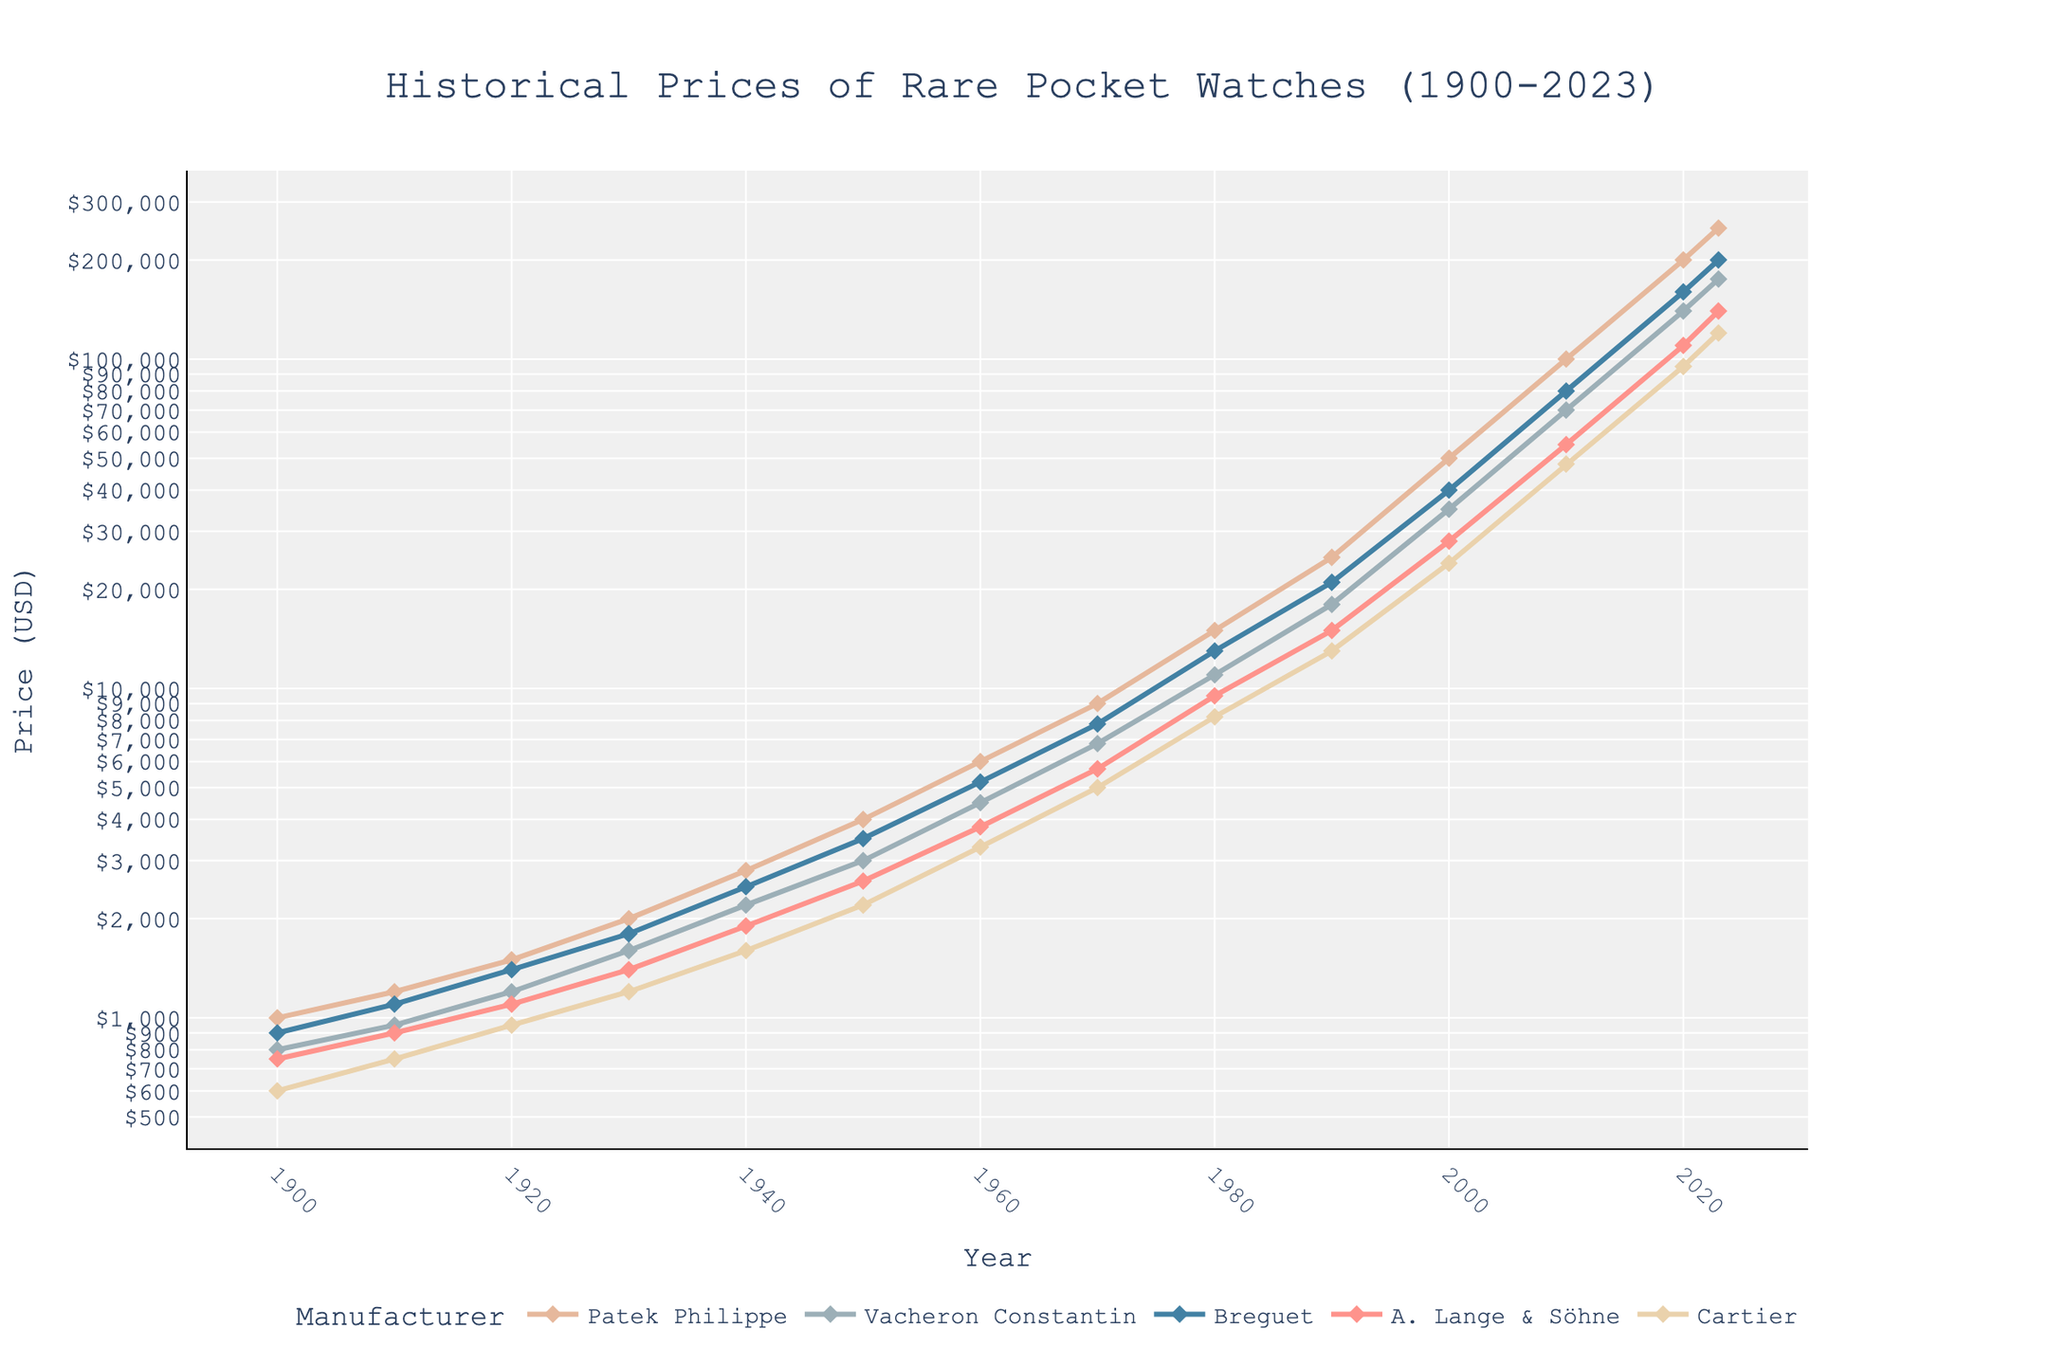Which manufacturer had the highest price in 2023? In 2023, the manufacturer with the highest price can be found by identifying the highest point on the y-axis for that year. Patek Philippe reached $250,000 in 2023, which is the highest among all manufacturers.
Answer: Patek Philippe What is the difference in prices between Patek Philippe and Cartier in 2020? To find the difference, look at the prices of Patek Philippe and Cartier for the year 2020. Patek Philippe is at $200,000 and Cartier is at $95,000. Subtract Cartier's price from Patek Philippe's price: $200,000 - $95,000 = $105,000.
Answer: $105,000 Which manufacturer showed the most significant increase in price from 1900 to 2023? Determine the price increase for each manufacturer by subtracting the 1900 price from the 2023 price: 
- Patek Philippe: $250,000 - $1,000 = $249,000 
- Vacheron Constantin: $175,000 - $800 = $174,200 
- Breguet: $200,000 - $900 = $199,100 
- A. Lange & Söhne: $140,000 - $750 = $139,250 
- Cartier: $120,000 - $600 = $119,400 
Patek Philippe shows the most significant increase.
Answer: Patek Philippe On average, what was the price trend for Vacheron Constantin every 10 years from 1900 to 2020? To calculate the average trend, list the prices every decade, sum them, then divide by the number of data points. Prices: $800 (1900), $950 (1910), $1200 (1920), $1600 (1930), $2200 (1940), $3000 (1950), $4500 (1960), $6800 (1970), $11000 (1980), $18000 (1990), $35000 (2000), $70000 (2010), $140000 (2020). Sum: $252050, number of decades: 13. Average: $252050 / 13 = $19388.
Answer: $19388 Between which two decades did Breguet see the largest absolute price increase? Calculate the price increase for each decade, then identify the largest: 
- 1900-1910: $1100 - $900 = $200
- 1910-1920: $1400 - $1100 = $300
- 1920-1930: $1800 - $1400 = $400
- 1930-1940: $2500 - $1800 = $700
- 1940-1950: $3500 - $2500 = $1000
- 1950-1960: $5200 - $3500 = $1700
- 1960-1970: $7800 - $5200 = $2600
- 1970-1980: $13000 - $7800 = $5200
- 1980-1990: $21000 - $13000 = $8000
- 1990-2000: $40000 - $21000 = $19000
- 2000-2010: $80000 - $40000 = $40000
- 2010-2020: $160000 - $80000 = $80000
The largest absolute increase is between 2010 and 2020.
Answer: 2010-2020 How does the price of A. Lange & Söhne in 2000 compare to the prices of Patek Philippe and Vacheron Constantin in 1980? In 2000, A. Lange & Söhne is priced at $28000, while in 1980, Patek Philippe is $15000 and Vacheron Constantin is $11000. A. Lange & Söhne's price in 2000 is higher than both Patek Philippe and Vacheron Constantin's prices in 1980.
Answer: Higher What is the visual pattern of the price trend for Cartier from 1900 to 2023? The price trend for Cartier shows a steady increase over time with no sharp dips or dramatic spikes. The line smoothly ascends from 1900 ($600) to 2023 ($120,000).
Answer: Steady increase How many times did the price of Breguet double from 1930 to 2020? The prices of Breguet in 1930 and 2020 are $1800 and $160000 respectively. Doubling $1800 four times gives approximate values: $3600 → $7200 → $14400 → $28800 → $57600 → $115200. Since $115200 < $160000, it doubled more than four but less than five times, exactly four times as $1800 doubled to $3600, to $7200, to $14400, and to $28800.
Answer: 4 times 